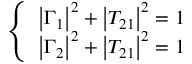<formula> <loc_0><loc_0><loc_500><loc_500>\left \{ \begin{array} { l } { \left | \Gamma _ { 1 } \right | ^ { 2 } + \left | T _ { 2 1 } \right | ^ { 2 } = 1 } \\ { \left | \Gamma _ { 2 } \right | ^ { 2 } + \left | T _ { 2 1 } \right | ^ { 2 } = 1 } \end{array}</formula> 